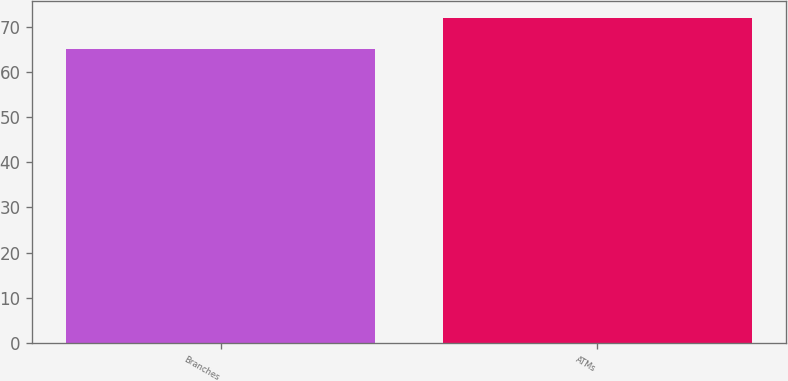Convert chart to OTSL. <chart><loc_0><loc_0><loc_500><loc_500><bar_chart><fcel>Branches<fcel>ATMs<nl><fcel>65<fcel>72<nl></chart> 